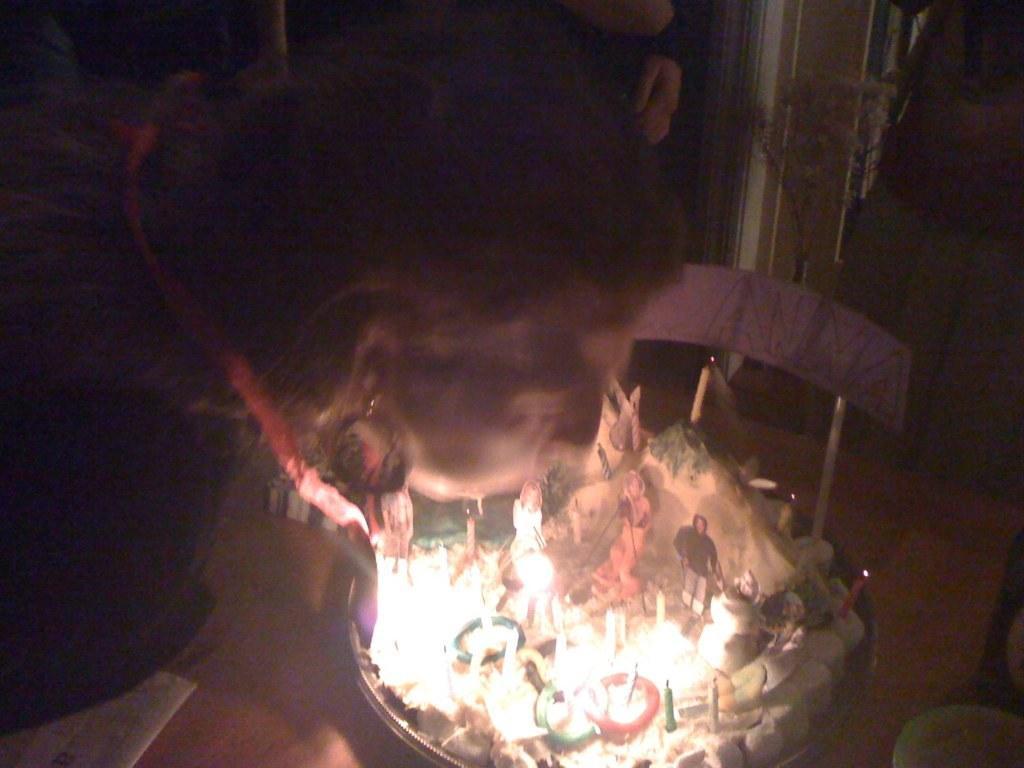Can you describe this image briefly? In the image there is a woman, she is blowing the candles on a cake in front of her, the cake is kept on a chair. 